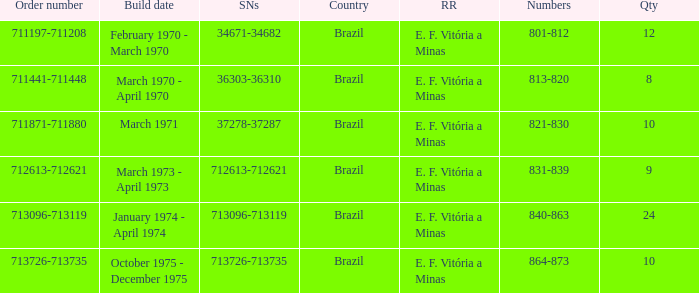What are the numbers for the order number 713096-713119? 840-863. 